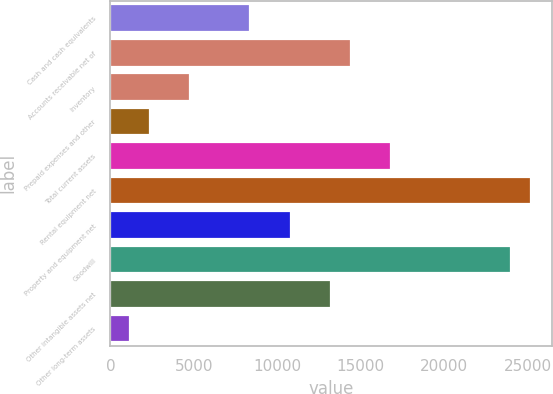Convert chart. <chart><loc_0><loc_0><loc_500><loc_500><bar_chart><fcel>Cash and cash equivalents<fcel>Accounts receivable net of<fcel>Inventory<fcel>Prepaid expenses and other<fcel>Total current assets<fcel>Rental equipment net<fcel>Property and equipment net<fcel>Goodwill<fcel>Other intangible assets net<fcel>Other long-term assets<nl><fcel>8391.9<fcel>14385.4<fcel>4795.8<fcel>2398.4<fcel>16782.8<fcel>25173.7<fcel>10789.3<fcel>23975<fcel>13186.7<fcel>1199.7<nl></chart> 